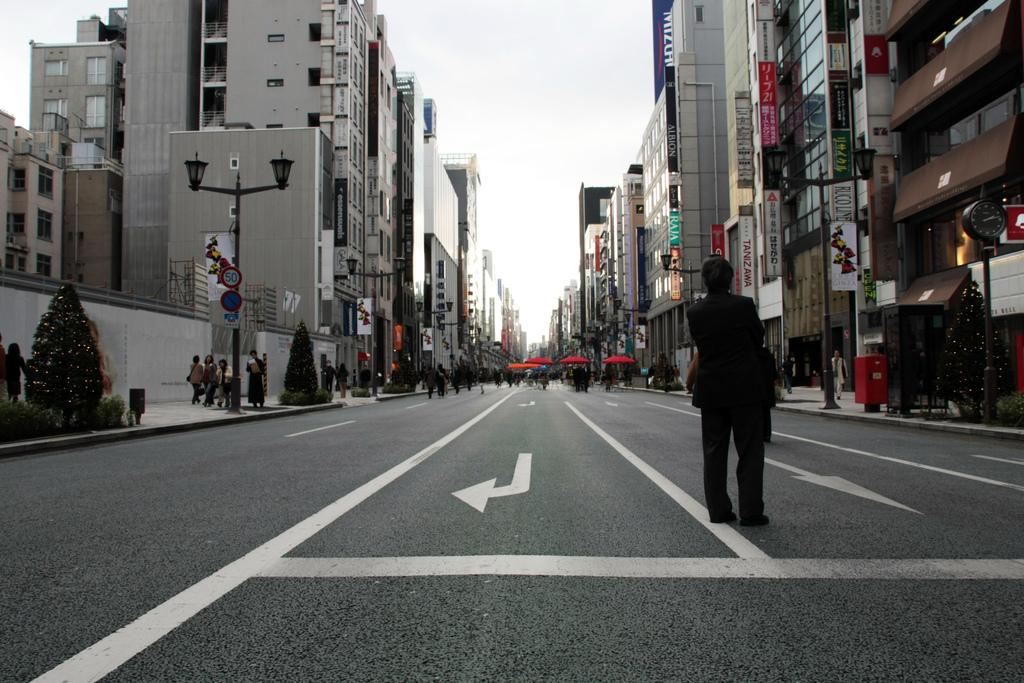What type of structures can be seen in the image? There are buildings in the image. What natural elements are present in the image? There are trees and plants in the image. What man-made objects can be seen in the image? There are poles in the image. Are there any people in the image? Yes, there are people in the image. What objects might be used for protection from the sun or rain in the image? There are umbrellas in the image. What type of signage is present in the image? There are boards with text and images in the image. What can be seen at ground level in the image? The ground is visible in the image. What part of the natural environment is visible in the image? The sky is visible in the image. What type of floor can be seen in the image? There is no specific floor mentioned in the image; it only shows buildings, trees, poles, people, umbrellas, plants, boards, ground, and sky. What type of leaf is present in the image? There is no leaf mentioned in the image; it only shows buildings, trees, poles, people, umbrellas, plants, boards, ground, and sky. 